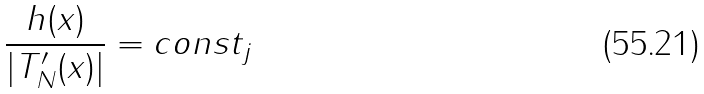<formula> <loc_0><loc_0><loc_500><loc_500>\frac { h ( x ) } { | T _ { N } ^ { \prime } ( x ) | } = c o n s t _ { j }</formula> 